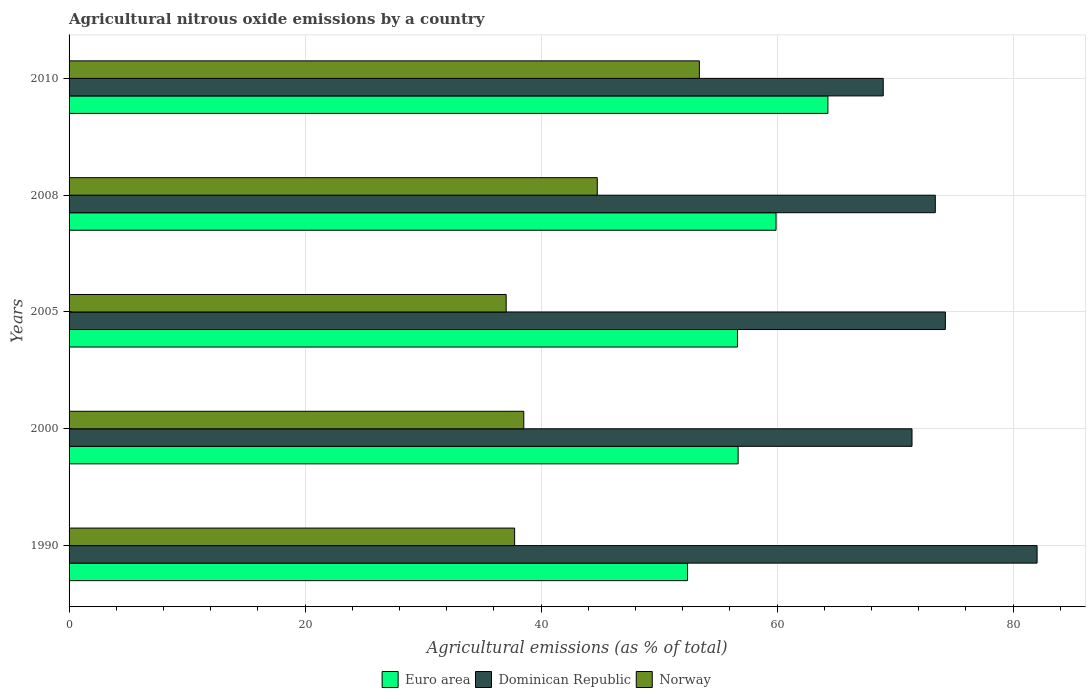How many different coloured bars are there?
Ensure brevity in your answer.  3. How many groups of bars are there?
Your answer should be very brief. 5. Are the number of bars on each tick of the Y-axis equal?
Keep it short and to the point. Yes. How many bars are there on the 1st tick from the bottom?
Offer a very short reply. 3. What is the label of the 4th group of bars from the top?
Keep it short and to the point. 2000. In how many cases, is the number of bars for a given year not equal to the number of legend labels?
Make the answer very short. 0. What is the amount of agricultural nitrous oxide emitted in Norway in 2010?
Offer a terse response. 53.41. Across all years, what is the maximum amount of agricultural nitrous oxide emitted in Euro area?
Your answer should be compact. 64.3. Across all years, what is the minimum amount of agricultural nitrous oxide emitted in Euro area?
Give a very brief answer. 52.41. In which year was the amount of agricultural nitrous oxide emitted in Euro area maximum?
Your response must be concise. 2010. In which year was the amount of agricultural nitrous oxide emitted in Euro area minimum?
Offer a terse response. 1990. What is the total amount of agricultural nitrous oxide emitted in Dominican Republic in the graph?
Provide a short and direct response. 370.09. What is the difference between the amount of agricultural nitrous oxide emitted in Norway in 2000 and that in 2005?
Keep it short and to the point. 1.49. What is the difference between the amount of agricultural nitrous oxide emitted in Euro area in 2010 and the amount of agricultural nitrous oxide emitted in Norway in 2008?
Provide a succinct answer. 19.54. What is the average amount of agricultural nitrous oxide emitted in Euro area per year?
Your response must be concise. 57.99. In the year 2000, what is the difference between the amount of agricultural nitrous oxide emitted in Norway and amount of agricultural nitrous oxide emitted in Dominican Republic?
Keep it short and to the point. -32.9. What is the ratio of the amount of agricultural nitrous oxide emitted in Norway in 2000 to that in 2008?
Ensure brevity in your answer.  0.86. Is the amount of agricultural nitrous oxide emitted in Dominican Republic in 1990 less than that in 2008?
Your response must be concise. No. Is the difference between the amount of agricultural nitrous oxide emitted in Norway in 1990 and 2010 greater than the difference between the amount of agricultural nitrous oxide emitted in Dominican Republic in 1990 and 2010?
Make the answer very short. No. What is the difference between the highest and the second highest amount of agricultural nitrous oxide emitted in Euro area?
Offer a terse response. 4.39. What is the difference between the highest and the lowest amount of agricultural nitrous oxide emitted in Euro area?
Offer a terse response. 11.89. In how many years, is the amount of agricultural nitrous oxide emitted in Dominican Republic greater than the average amount of agricultural nitrous oxide emitted in Dominican Republic taken over all years?
Offer a terse response. 2. Is the sum of the amount of agricultural nitrous oxide emitted in Norway in 1990 and 2010 greater than the maximum amount of agricultural nitrous oxide emitted in Euro area across all years?
Provide a succinct answer. Yes. Is it the case that in every year, the sum of the amount of agricultural nitrous oxide emitted in Norway and amount of agricultural nitrous oxide emitted in Euro area is greater than the amount of agricultural nitrous oxide emitted in Dominican Republic?
Ensure brevity in your answer.  Yes. How many bars are there?
Keep it short and to the point. 15. Are all the bars in the graph horizontal?
Make the answer very short. Yes. How many years are there in the graph?
Your response must be concise. 5. Are the values on the major ticks of X-axis written in scientific E-notation?
Ensure brevity in your answer.  No. Does the graph contain any zero values?
Keep it short and to the point. No. Where does the legend appear in the graph?
Provide a short and direct response. Bottom center. How many legend labels are there?
Provide a short and direct response. 3. What is the title of the graph?
Offer a terse response. Agricultural nitrous oxide emissions by a country. Does "Ethiopia" appear as one of the legend labels in the graph?
Ensure brevity in your answer.  No. What is the label or title of the X-axis?
Ensure brevity in your answer.  Agricultural emissions (as % of total). What is the label or title of the Y-axis?
Your answer should be compact. Years. What is the Agricultural emissions (as % of total) of Euro area in 1990?
Provide a succinct answer. 52.41. What is the Agricultural emissions (as % of total) of Dominican Republic in 1990?
Provide a short and direct response. 82.03. What is the Agricultural emissions (as % of total) in Norway in 1990?
Make the answer very short. 37.76. What is the Agricultural emissions (as % of total) in Euro area in 2000?
Make the answer very short. 56.69. What is the Agricultural emissions (as % of total) of Dominican Republic in 2000?
Your response must be concise. 71.43. What is the Agricultural emissions (as % of total) in Norway in 2000?
Provide a succinct answer. 38.53. What is the Agricultural emissions (as % of total) in Euro area in 2005?
Your response must be concise. 56.64. What is the Agricultural emissions (as % of total) of Dominican Republic in 2005?
Your answer should be compact. 74.25. What is the Agricultural emissions (as % of total) in Norway in 2005?
Make the answer very short. 37.04. What is the Agricultural emissions (as % of total) of Euro area in 2008?
Give a very brief answer. 59.91. What is the Agricultural emissions (as % of total) of Dominican Republic in 2008?
Your answer should be very brief. 73.4. What is the Agricultural emissions (as % of total) of Norway in 2008?
Your answer should be compact. 44.76. What is the Agricultural emissions (as % of total) of Euro area in 2010?
Give a very brief answer. 64.3. What is the Agricultural emissions (as % of total) in Dominican Republic in 2010?
Offer a very short reply. 68.99. What is the Agricultural emissions (as % of total) of Norway in 2010?
Your answer should be compact. 53.41. Across all years, what is the maximum Agricultural emissions (as % of total) in Euro area?
Your response must be concise. 64.3. Across all years, what is the maximum Agricultural emissions (as % of total) of Dominican Republic?
Give a very brief answer. 82.03. Across all years, what is the maximum Agricultural emissions (as % of total) in Norway?
Give a very brief answer. 53.41. Across all years, what is the minimum Agricultural emissions (as % of total) in Euro area?
Your response must be concise. 52.41. Across all years, what is the minimum Agricultural emissions (as % of total) of Dominican Republic?
Provide a succinct answer. 68.99. Across all years, what is the minimum Agricultural emissions (as % of total) in Norway?
Provide a short and direct response. 37.04. What is the total Agricultural emissions (as % of total) of Euro area in the graph?
Your answer should be compact. 289.94. What is the total Agricultural emissions (as % of total) in Dominican Republic in the graph?
Your answer should be very brief. 370.09. What is the total Agricultural emissions (as % of total) of Norway in the graph?
Keep it short and to the point. 211.49. What is the difference between the Agricultural emissions (as % of total) of Euro area in 1990 and that in 2000?
Ensure brevity in your answer.  -4.28. What is the difference between the Agricultural emissions (as % of total) of Dominican Republic in 1990 and that in 2000?
Offer a terse response. 10.6. What is the difference between the Agricultural emissions (as % of total) of Norway in 1990 and that in 2000?
Offer a very short reply. -0.78. What is the difference between the Agricultural emissions (as % of total) of Euro area in 1990 and that in 2005?
Keep it short and to the point. -4.23. What is the difference between the Agricultural emissions (as % of total) of Dominican Republic in 1990 and that in 2005?
Provide a short and direct response. 7.77. What is the difference between the Agricultural emissions (as % of total) of Norway in 1990 and that in 2005?
Make the answer very short. 0.72. What is the difference between the Agricultural emissions (as % of total) in Euro area in 1990 and that in 2008?
Your answer should be very brief. -7.5. What is the difference between the Agricultural emissions (as % of total) in Dominican Republic in 1990 and that in 2008?
Your response must be concise. 8.63. What is the difference between the Agricultural emissions (as % of total) of Norway in 1990 and that in 2008?
Offer a terse response. -7. What is the difference between the Agricultural emissions (as % of total) in Euro area in 1990 and that in 2010?
Your response must be concise. -11.89. What is the difference between the Agricultural emissions (as % of total) of Dominican Republic in 1990 and that in 2010?
Offer a very short reply. 13.04. What is the difference between the Agricultural emissions (as % of total) of Norway in 1990 and that in 2010?
Your response must be concise. -15.65. What is the difference between the Agricultural emissions (as % of total) in Euro area in 2000 and that in 2005?
Provide a short and direct response. 0.05. What is the difference between the Agricultural emissions (as % of total) in Dominican Republic in 2000 and that in 2005?
Make the answer very short. -2.83. What is the difference between the Agricultural emissions (as % of total) in Norway in 2000 and that in 2005?
Offer a terse response. 1.49. What is the difference between the Agricultural emissions (as % of total) of Euro area in 2000 and that in 2008?
Give a very brief answer. -3.21. What is the difference between the Agricultural emissions (as % of total) of Dominican Republic in 2000 and that in 2008?
Keep it short and to the point. -1.97. What is the difference between the Agricultural emissions (as % of total) of Norway in 2000 and that in 2008?
Ensure brevity in your answer.  -6.23. What is the difference between the Agricultural emissions (as % of total) of Euro area in 2000 and that in 2010?
Keep it short and to the point. -7.61. What is the difference between the Agricultural emissions (as % of total) of Dominican Republic in 2000 and that in 2010?
Offer a very short reply. 2.44. What is the difference between the Agricultural emissions (as % of total) of Norway in 2000 and that in 2010?
Ensure brevity in your answer.  -14.88. What is the difference between the Agricultural emissions (as % of total) of Euro area in 2005 and that in 2008?
Keep it short and to the point. -3.27. What is the difference between the Agricultural emissions (as % of total) of Dominican Republic in 2005 and that in 2008?
Your response must be concise. 0.85. What is the difference between the Agricultural emissions (as % of total) in Norway in 2005 and that in 2008?
Provide a succinct answer. -7.72. What is the difference between the Agricultural emissions (as % of total) of Euro area in 2005 and that in 2010?
Provide a succinct answer. -7.66. What is the difference between the Agricultural emissions (as % of total) of Dominican Republic in 2005 and that in 2010?
Keep it short and to the point. 5.27. What is the difference between the Agricultural emissions (as % of total) of Norway in 2005 and that in 2010?
Ensure brevity in your answer.  -16.37. What is the difference between the Agricultural emissions (as % of total) of Euro area in 2008 and that in 2010?
Offer a very short reply. -4.39. What is the difference between the Agricultural emissions (as % of total) in Dominican Republic in 2008 and that in 2010?
Your answer should be very brief. 4.41. What is the difference between the Agricultural emissions (as % of total) of Norway in 2008 and that in 2010?
Provide a succinct answer. -8.65. What is the difference between the Agricultural emissions (as % of total) in Euro area in 1990 and the Agricultural emissions (as % of total) in Dominican Republic in 2000?
Your answer should be compact. -19.02. What is the difference between the Agricultural emissions (as % of total) in Euro area in 1990 and the Agricultural emissions (as % of total) in Norway in 2000?
Keep it short and to the point. 13.88. What is the difference between the Agricultural emissions (as % of total) of Dominican Republic in 1990 and the Agricultural emissions (as % of total) of Norway in 2000?
Ensure brevity in your answer.  43.49. What is the difference between the Agricultural emissions (as % of total) of Euro area in 1990 and the Agricultural emissions (as % of total) of Dominican Republic in 2005?
Ensure brevity in your answer.  -21.85. What is the difference between the Agricultural emissions (as % of total) in Euro area in 1990 and the Agricultural emissions (as % of total) in Norway in 2005?
Keep it short and to the point. 15.37. What is the difference between the Agricultural emissions (as % of total) in Dominican Republic in 1990 and the Agricultural emissions (as % of total) in Norway in 2005?
Your answer should be very brief. 44.99. What is the difference between the Agricultural emissions (as % of total) of Euro area in 1990 and the Agricultural emissions (as % of total) of Dominican Republic in 2008?
Make the answer very short. -20.99. What is the difference between the Agricultural emissions (as % of total) in Euro area in 1990 and the Agricultural emissions (as % of total) in Norway in 2008?
Offer a very short reply. 7.65. What is the difference between the Agricultural emissions (as % of total) in Dominican Republic in 1990 and the Agricultural emissions (as % of total) in Norway in 2008?
Your response must be concise. 37.27. What is the difference between the Agricultural emissions (as % of total) in Euro area in 1990 and the Agricultural emissions (as % of total) in Dominican Republic in 2010?
Offer a terse response. -16.58. What is the difference between the Agricultural emissions (as % of total) of Euro area in 1990 and the Agricultural emissions (as % of total) of Norway in 2010?
Offer a terse response. -1. What is the difference between the Agricultural emissions (as % of total) of Dominican Republic in 1990 and the Agricultural emissions (as % of total) of Norway in 2010?
Make the answer very short. 28.62. What is the difference between the Agricultural emissions (as % of total) in Euro area in 2000 and the Agricultural emissions (as % of total) in Dominican Republic in 2005?
Your answer should be very brief. -17.56. What is the difference between the Agricultural emissions (as % of total) of Euro area in 2000 and the Agricultural emissions (as % of total) of Norway in 2005?
Provide a short and direct response. 19.65. What is the difference between the Agricultural emissions (as % of total) in Dominican Republic in 2000 and the Agricultural emissions (as % of total) in Norway in 2005?
Offer a very short reply. 34.39. What is the difference between the Agricultural emissions (as % of total) in Euro area in 2000 and the Agricultural emissions (as % of total) in Dominican Republic in 2008?
Offer a very short reply. -16.71. What is the difference between the Agricultural emissions (as % of total) in Euro area in 2000 and the Agricultural emissions (as % of total) in Norway in 2008?
Provide a short and direct response. 11.93. What is the difference between the Agricultural emissions (as % of total) in Dominican Republic in 2000 and the Agricultural emissions (as % of total) in Norway in 2008?
Provide a succinct answer. 26.67. What is the difference between the Agricultural emissions (as % of total) of Euro area in 2000 and the Agricultural emissions (as % of total) of Dominican Republic in 2010?
Offer a very short reply. -12.29. What is the difference between the Agricultural emissions (as % of total) in Euro area in 2000 and the Agricultural emissions (as % of total) in Norway in 2010?
Provide a short and direct response. 3.28. What is the difference between the Agricultural emissions (as % of total) in Dominican Republic in 2000 and the Agricultural emissions (as % of total) in Norway in 2010?
Ensure brevity in your answer.  18.02. What is the difference between the Agricultural emissions (as % of total) in Euro area in 2005 and the Agricultural emissions (as % of total) in Dominican Republic in 2008?
Your answer should be compact. -16.76. What is the difference between the Agricultural emissions (as % of total) of Euro area in 2005 and the Agricultural emissions (as % of total) of Norway in 2008?
Your answer should be very brief. 11.88. What is the difference between the Agricultural emissions (as % of total) of Dominican Republic in 2005 and the Agricultural emissions (as % of total) of Norway in 2008?
Provide a succinct answer. 29.5. What is the difference between the Agricultural emissions (as % of total) in Euro area in 2005 and the Agricultural emissions (as % of total) in Dominican Republic in 2010?
Your response must be concise. -12.35. What is the difference between the Agricultural emissions (as % of total) of Euro area in 2005 and the Agricultural emissions (as % of total) of Norway in 2010?
Make the answer very short. 3.23. What is the difference between the Agricultural emissions (as % of total) in Dominican Republic in 2005 and the Agricultural emissions (as % of total) in Norway in 2010?
Your response must be concise. 20.84. What is the difference between the Agricultural emissions (as % of total) of Euro area in 2008 and the Agricultural emissions (as % of total) of Dominican Republic in 2010?
Offer a terse response. -9.08. What is the difference between the Agricultural emissions (as % of total) of Euro area in 2008 and the Agricultural emissions (as % of total) of Norway in 2010?
Provide a short and direct response. 6.5. What is the difference between the Agricultural emissions (as % of total) of Dominican Republic in 2008 and the Agricultural emissions (as % of total) of Norway in 2010?
Provide a succinct answer. 19.99. What is the average Agricultural emissions (as % of total) in Euro area per year?
Your answer should be very brief. 57.99. What is the average Agricultural emissions (as % of total) in Dominican Republic per year?
Your response must be concise. 74.02. What is the average Agricultural emissions (as % of total) in Norway per year?
Give a very brief answer. 42.3. In the year 1990, what is the difference between the Agricultural emissions (as % of total) of Euro area and Agricultural emissions (as % of total) of Dominican Republic?
Keep it short and to the point. -29.62. In the year 1990, what is the difference between the Agricultural emissions (as % of total) in Euro area and Agricultural emissions (as % of total) in Norway?
Make the answer very short. 14.65. In the year 1990, what is the difference between the Agricultural emissions (as % of total) of Dominican Republic and Agricultural emissions (as % of total) of Norway?
Ensure brevity in your answer.  44.27. In the year 2000, what is the difference between the Agricultural emissions (as % of total) in Euro area and Agricultural emissions (as % of total) in Dominican Republic?
Your response must be concise. -14.73. In the year 2000, what is the difference between the Agricultural emissions (as % of total) in Euro area and Agricultural emissions (as % of total) in Norway?
Your response must be concise. 18.16. In the year 2000, what is the difference between the Agricultural emissions (as % of total) in Dominican Republic and Agricultural emissions (as % of total) in Norway?
Keep it short and to the point. 32.9. In the year 2005, what is the difference between the Agricultural emissions (as % of total) of Euro area and Agricultural emissions (as % of total) of Dominican Republic?
Offer a very short reply. -17.62. In the year 2005, what is the difference between the Agricultural emissions (as % of total) in Euro area and Agricultural emissions (as % of total) in Norway?
Offer a terse response. 19.6. In the year 2005, what is the difference between the Agricultural emissions (as % of total) in Dominican Republic and Agricultural emissions (as % of total) in Norway?
Your response must be concise. 37.21. In the year 2008, what is the difference between the Agricultural emissions (as % of total) in Euro area and Agricultural emissions (as % of total) in Dominican Republic?
Your answer should be very brief. -13.49. In the year 2008, what is the difference between the Agricultural emissions (as % of total) of Euro area and Agricultural emissions (as % of total) of Norway?
Ensure brevity in your answer.  15.15. In the year 2008, what is the difference between the Agricultural emissions (as % of total) in Dominican Republic and Agricultural emissions (as % of total) in Norway?
Give a very brief answer. 28.64. In the year 2010, what is the difference between the Agricultural emissions (as % of total) in Euro area and Agricultural emissions (as % of total) in Dominican Republic?
Offer a terse response. -4.69. In the year 2010, what is the difference between the Agricultural emissions (as % of total) of Euro area and Agricultural emissions (as % of total) of Norway?
Offer a very short reply. 10.89. In the year 2010, what is the difference between the Agricultural emissions (as % of total) in Dominican Republic and Agricultural emissions (as % of total) in Norway?
Make the answer very short. 15.58. What is the ratio of the Agricultural emissions (as % of total) in Euro area in 1990 to that in 2000?
Make the answer very short. 0.92. What is the ratio of the Agricultural emissions (as % of total) of Dominican Republic in 1990 to that in 2000?
Your answer should be compact. 1.15. What is the ratio of the Agricultural emissions (as % of total) in Norway in 1990 to that in 2000?
Ensure brevity in your answer.  0.98. What is the ratio of the Agricultural emissions (as % of total) in Euro area in 1990 to that in 2005?
Provide a short and direct response. 0.93. What is the ratio of the Agricultural emissions (as % of total) of Dominican Republic in 1990 to that in 2005?
Provide a short and direct response. 1.1. What is the ratio of the Agricultural emissions (as % of total) in Norway in 1990 to that in 2005?
Provide a short and direct response. 1.02. What is the ratio of the Agricultural emissions (as % of total) of Euro area in 1990 to that in 2008?
Offer a terse response. 0.87. What is the ratio of the Agricultural emissions (as % of total) of Dominican Republic in 1990 to that in 2008?
Provide a succinct answer. 1.12. What is the ratio of the Agricultural emissions (as % of total) in Norway in 1990 to that in 2008?
Offer a terse response. 0.84. What is the ratio of the Agricultural emissions (as % of total) in Euro area in 1990 to that in 2010?
Offer a terse response. 0.81. What is the ratio of the Agricultural emissions (as % of total) in Dominican Republic in 1990 to that in 2010?
Offer a very short reply. 1.19. What is the ratio of the Agricultural emissions (as % of total) of Norway in 1990 to that in 2010?
Provide a short and direct response. 0.71. What is the ratio of the Agricultural emissions (as % of total) in Euro area in 2000 to that in 2005?
Your answer should be very brief. 1. What is the ratio of the Agricultural emissions (as % of total) of Dominican Republic in 2000 to that in 2005?
Offer a terse response. 0.96. What is the ratio of the Agricultural emissions (as % of total) in Norway in 2000 to that in 2005?
Ensure brevity in your answer.  1.04. What is the ratio of the Agricultural emissions (as % of total) in Euro area in 2000 to that in 2008?
Your answer should be compact. 0.95. What is the ratio of the Agricultural emissions (as % of total) in Dominican Republic in 2000 to that in 2008?
Offer a very short reply. 0.97. What is the ratio of the Agricultural emissions (as % of total) in Norway in 2000 to that in 2008?
Offer a very short reply. 0.86. What is the ratio of the Agricultural emissions (as % of total) in Euro area in 2000 to that in 2010?
Give a very brief answer. 0.88. What is the ratio of the Agricultural emissions (as % of total) of Dominican Republic in 2000 to that in 2010?
Provide a succinct answer. 1.04. What is the ratio of the Agricultural emissions (as % of total) in Norway in 2000 to that in 2010?
Your answer should be compact. 0.72. What is the ratio of the Agricultural emissions (as % of total) of Euro area in 2005 to that in 2008?
Your answer should be compact. 0.95. What is the ratio of the Agricultural emissions (as % of total) of Dominican Republic in 2005 to that in 2008?
Your answer should be very brief. 1.01. What is the ratio of the Agricultural emissions (as % of total) of Norway in 2005 to that in 2008?
Make the answer very short. 0.83. What is the ratio of the Agricultural emissions (as % of total) of Euro area in 2005 to that in 2010?
Your answer should be compact. 0.88. What is the ratio of the Agricultural emissions (as % of total) in Dominican Republic in 2005 to that in 2010?
Give a very brief answer. 1.08. What is the ratio of the Agricultural emissions (as % of total) in Norway in 2005 to that in 2010?
Ensure brevity in your answer.  0.69. What is the ratio of the Agricultural emissions (as % of total) of Euro area in 2008 to that in 2010?
Offer a very short reply. 0.93. What is the ratio of the Agricultural emissions (as % of total) in Dominican Republic in 2008 to that in 2010?
Offer a terse response. 1.06. What is the ratio of the Agricultural emissions (as % of total) of Norway in 2008 to that in 2010?
Make the answer very short. 0.84. What is the difference between the highest and the second highest Agricultural emissions (as % of total) of Euro area?
Make the answer very short. 4.39. What is the difference between the highest and the second highest Agricultural emissions (as % of total) in Dominican Republic?
Provide a short and direct response. 7.77. What is the difference between the highest and the second highest Agricultural emissions (as % of total) of Norway?
Provide a short and direct response. 8.65. What is the difference between the highest and the lowest Agricultural emissions (as % of total) in Euro area?
Offer a very short reply. 11.89. What is the difference between the highest and the lowest Agricultural emissions (as % of total) of Dominican Republic?
Keep it short and to the point. 13.04. What is the difference between the highest and the lowest Agricultural emissions (as % of total) in Norway?
Offer a terse response. 16.37. 